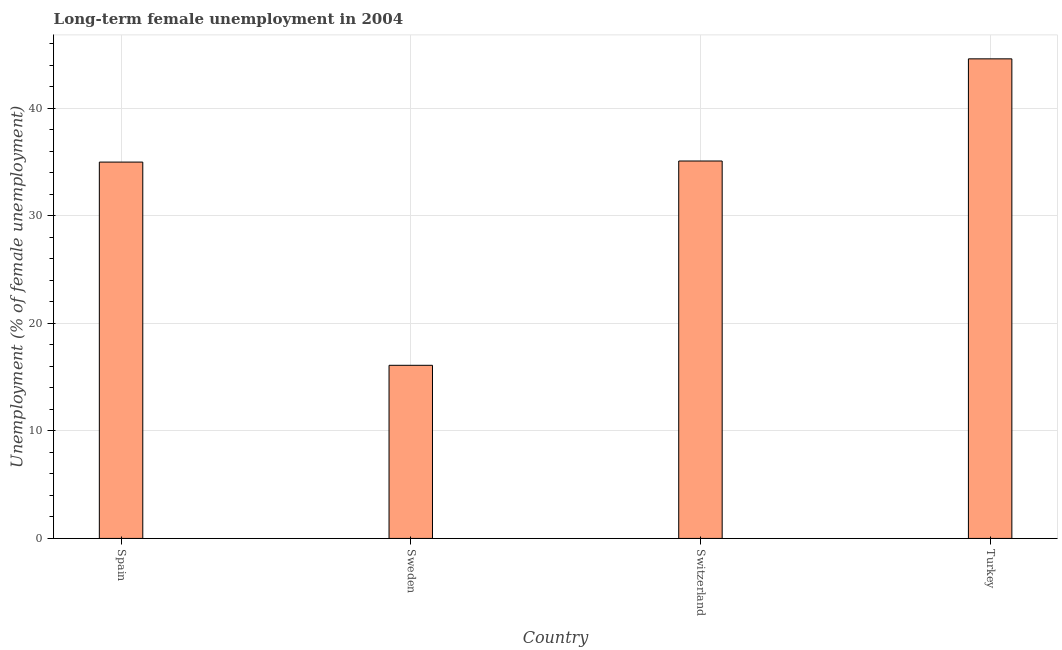What is the title of the graph?
Make the answer very short. Long-term female unemployment in 2004. What is the label or title of the Y-axis?
Give a very brief answer. Unemployment (% of female unemployment). What is the long-term female unemployment in Sweden?
Make the answer very short. 16.1. Across all countries, what is the maximum long-term female unemployment?
Your answer should be compact. 44.6. Across all countries, what is the minimum long-term female unemployment?
Your answer should be compact. 16.1. In which country was the long-term female unemployment maximum?
Your response must be concise. Turkey. What is the sum of the long-term female unemployment?
Provide a succinct answer. 130.8. What is the difference between the long-term female unemployment in Switzerland and Turkey?
Keep it short and to the point. -9.5. What is the average long-term female unemployment per country?
Offer a very short reply. 32.7. What is the median long-term female unemployment?
Offer a very short reply. 35.05. What is the ratio of the long-term female unemployment in Spain to that in Turkey?
Provide a short and direct response. 0.79. Is the long-term female unemployment in Spain less than that in Turkey?
Make the answer very short. Yes. What is the difference between the highest and the lowest long-term female unemployment?
Ensure brevity in your answer.  28.5. In how many countries, is the long-term female unemployment greater than the average long-term female unemployment taken over all countries?
Provide a short and direct response. 3. How many bars are there?
Provide a succinct answer. 4. Are all the bars in the graph horizontal?
Give a very brief answer. No. What is the difference between two consecutive major ticks on the Y-axis?
Your response must be concise. 10. What is the Unemployment (% of female unemployment) in Sweden?
Your answer should be compact. 16.1. What is the Unemployment (% of female unemployment) of Switzerland?
Offer a very short reply. 35.1. What is the Unemployment (% of female unemployment) of Turkey?
Keep it short and to the point. 44.6. What is the difference between the Unemployment (% of female unemployment) in Spain and Turkey?
Provide a short and direct response. -9.6. What is the difference between the Unemployment (% of female unemployment) in Sweden and Turkey?
Keep it short and to the point. -28.5. What is the difference between the Unemployment (% of female unemployment) in Switzerland and Turkey?
Your response must be concise. -9.5. What is the ratio of the Unemployment (% of female unemployment) in Spain to that in Sweden?
Ensure brevity in your answer.  2.17. What is the ratio of the Unemployment (% of female unemployment) in Spain to that in Turkey?
Your answer should be very brief. 0.79. What is the ratio of the Unemployment (% of female unemployment) in Sweden to that in Switzerland?
Your answer should be compact. 0.46. What is the ratio of the Unemployment (% of female unemployment) in Sweden to that in Turkey?
Your response must be concise. 0.36. What is the ratio of the Unemployment (% of female unemployment) in Switzerland to that in Turkey?
Your answer should be very brief. 0.79. 